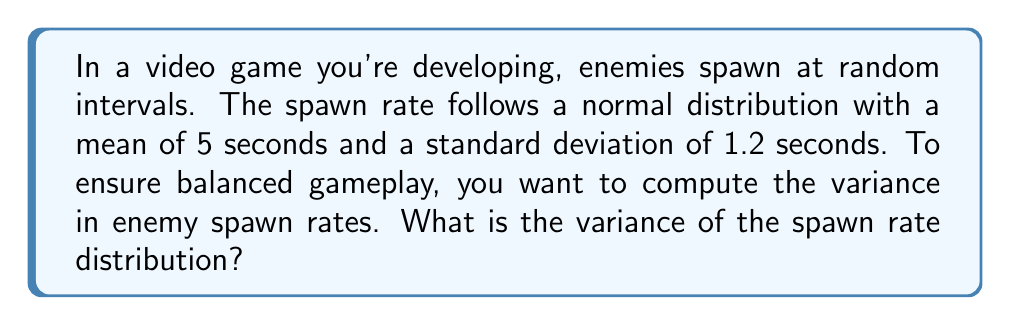Solve this math problem. To solve this problem, we need to understand the relationship between standard deviation and variance for a normal distribution.

1. Given information:
   - The spawn rate follows a normal distribution
   - Mean (μ) = 5 seconds
   - Standard deviation (σ) = 1.2 seconds

2. Relationship between variance and standard deviation:
   The variance (σ²) is the square of the standard deviation (σ).

3. Calculate the variance:
   $$\text{Variance} = \sigma^2 = (1.2)^2 = 1.44$$

Therefore, the variance of the enemy spawn rate distribution is 1.44 seconds².

This variance value gives us a measure of the spread of spawn times around the mean. A lower variance would indicate more consistent spawn rates, while a higher variance would result in more unpredictable spawn timing, potentially affecting game balance.
Answer: $1.44$ seconds² 